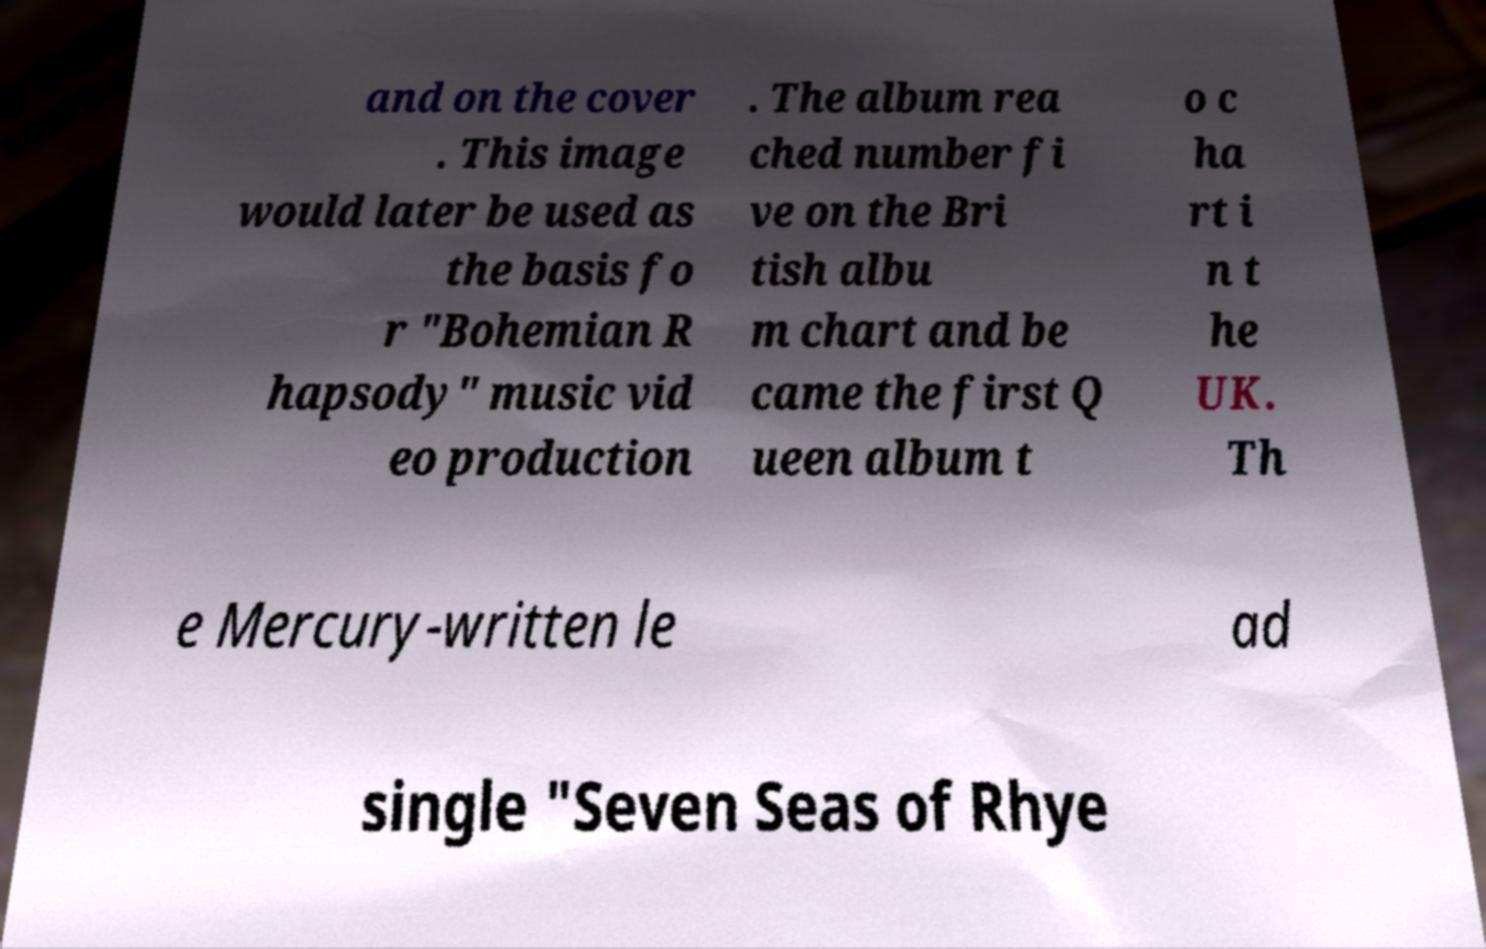Could you assist in decoding the text presented in this image and type it out clearly? and on the cover . This image would later be used as the basis fo r "Bohemian R hapsody" music vid eo production . The album rea ched number fi ve on the Bri tish albu m chart and be came the first Q ueen album t o c ha rt i n t he UK. Th e Mercury-written le ad single "Seven Seas of Rhye 